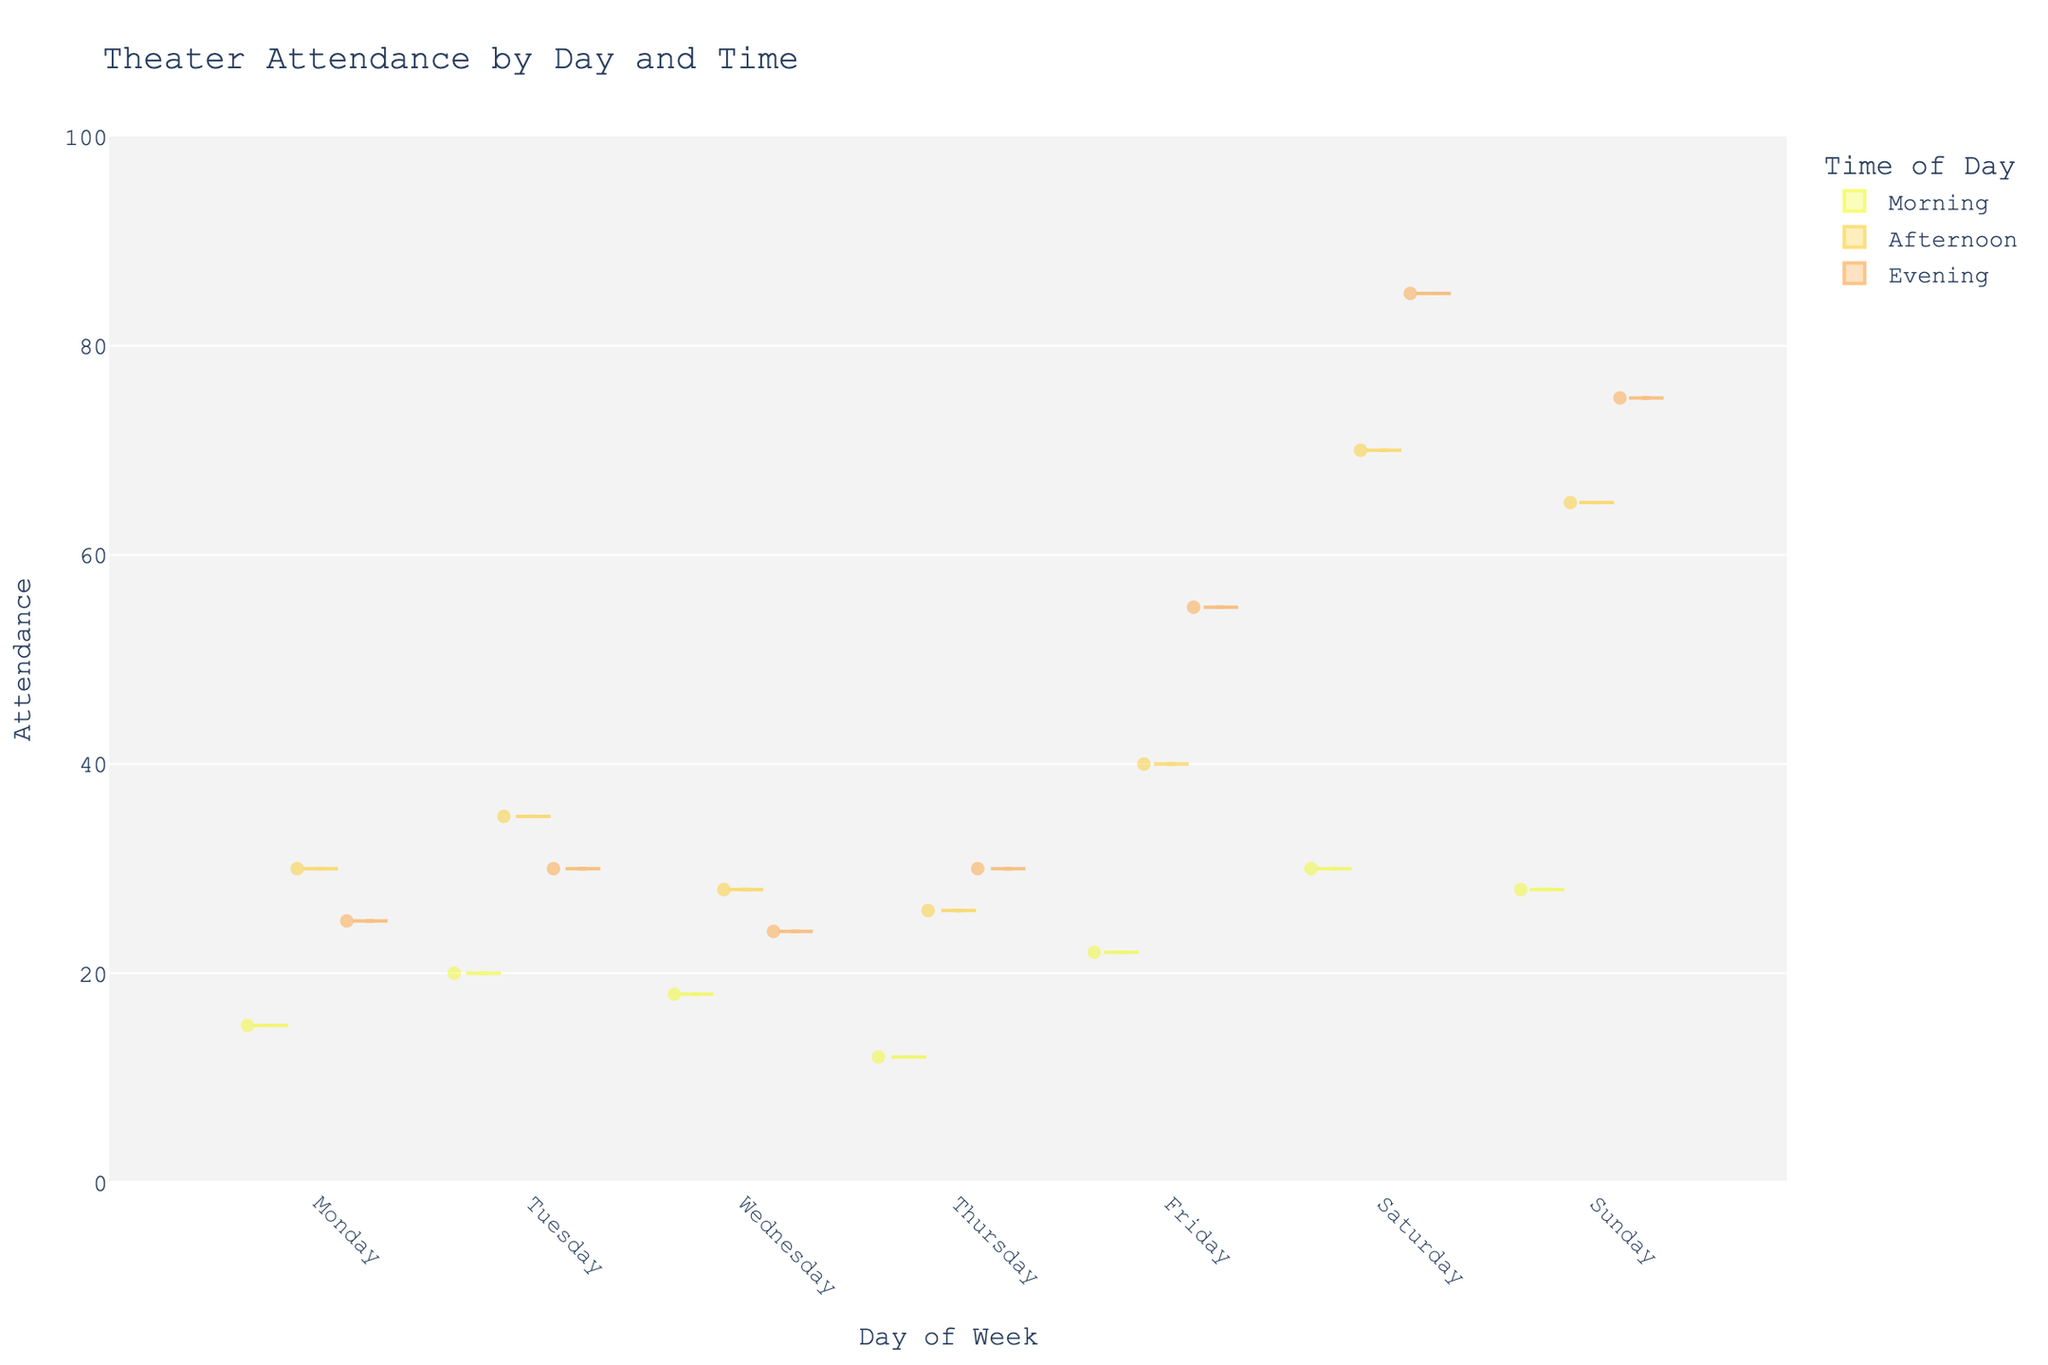what is the title of the violin chart? The title of the chart is typically found at the top of the visualization and summarises the entire plot in a few words.
Answer: Theater Attendance by Day and Time What does the y-axis represent in this chart? The y-axis is usually labeled to indicate what variable is being measured. In this figure, it is labeled "Attendance."
Answer: Attendance Which day of the week shows the highest attendance in the evening? By examining the evening attendance distribution for each day, Saturday evening shows the highest attendance concentration.
Answer: Saturday On which day was the widest range of attendance observed in the afternoon? By comparing the spread of the violin plots for each day in the afternoon, the widest range is seen on Saturday.
Answer: Saturday What is the average attendance for Thursday morning? Identify the jittered points within the Thursday morning section and calculate the mean of these attendance counts. The values are mostly clustered around 12.
Answer: 12 How does attendance compare between Friday afternoon and Saturday afternoon? By comparing the height and distribution of the violin plots, Saturday afternoon has a higher and wider range of attendance than Friday afternoon.
Answer: Saturday has higher attendance Which two days have the highest median attendance in the evening? Examining the central lines on the violin plots for evening times will show which days have the highest median value, which are Saturday and Sunday.
Answer: Saturday and Sunday What general trend can be observed from morning to evening across all days? By visually scanning the violin plots from morning through evening times, one can observe that attendance typically increases from morning to afternoon and peaks during the evening.
Answer: Attendance generally increases from morning to evening 